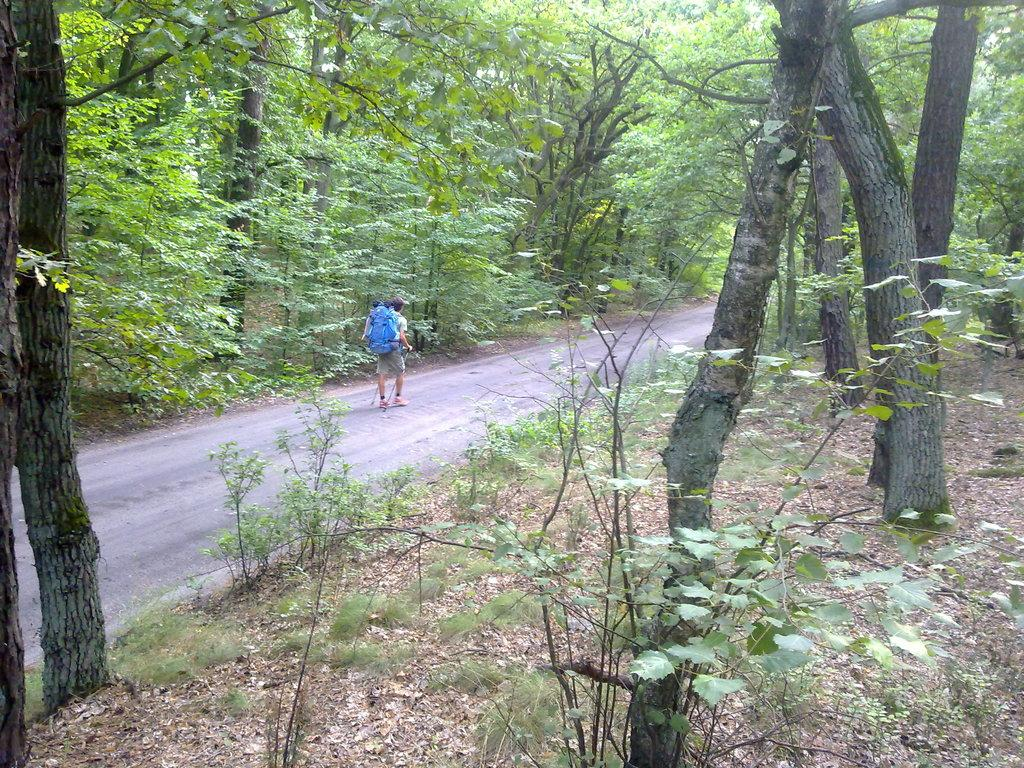What type of vegetation is in the front of the image? There are plants in the front of the image. What other type of vegetation can be seen in the image? There are trees in the image, both in the front and in the background. We start by identifying the types of vegetation present in the image, which are plants and trees. Then, we mention the person walking in the center of the image to provide more context about the scene. Finally, we describe the trees in the background to give a sense of the overall setting. Absurd Question/Answer: How many tickets does the person have in their hand in the image? There is no indication in the image that the person is holding any tickets. What type of weather can be seen in the image? There is no indication of weather in the image. Can you tell me how the person is turning in the image? There is no indication that the person is turning in the image; they are walking straight. 